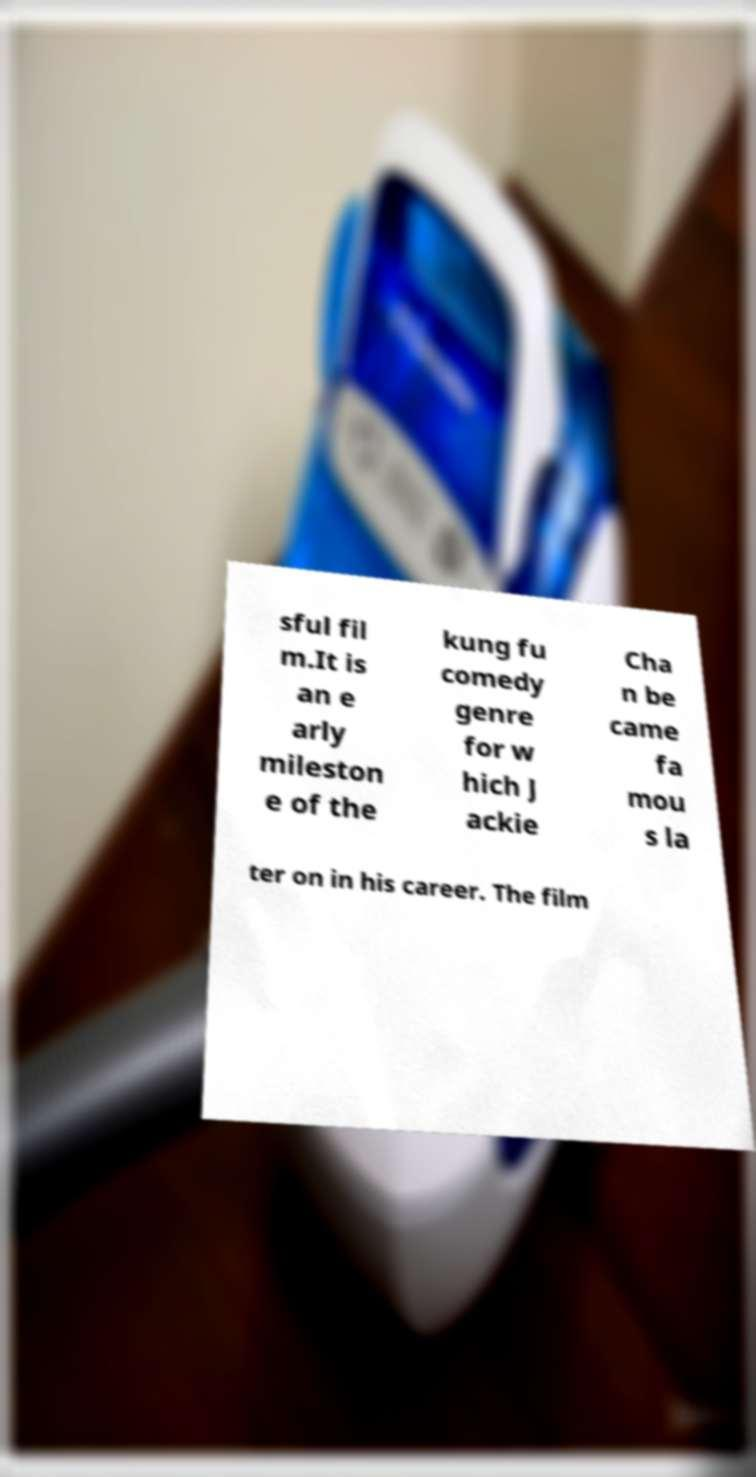Please identify and transcribe the text found in this image. sful fil m.It is an e arly mileston e of the kung fu comedy genre for w hich J ackie Cha n be came fa mou s la ter on in his career. The film 